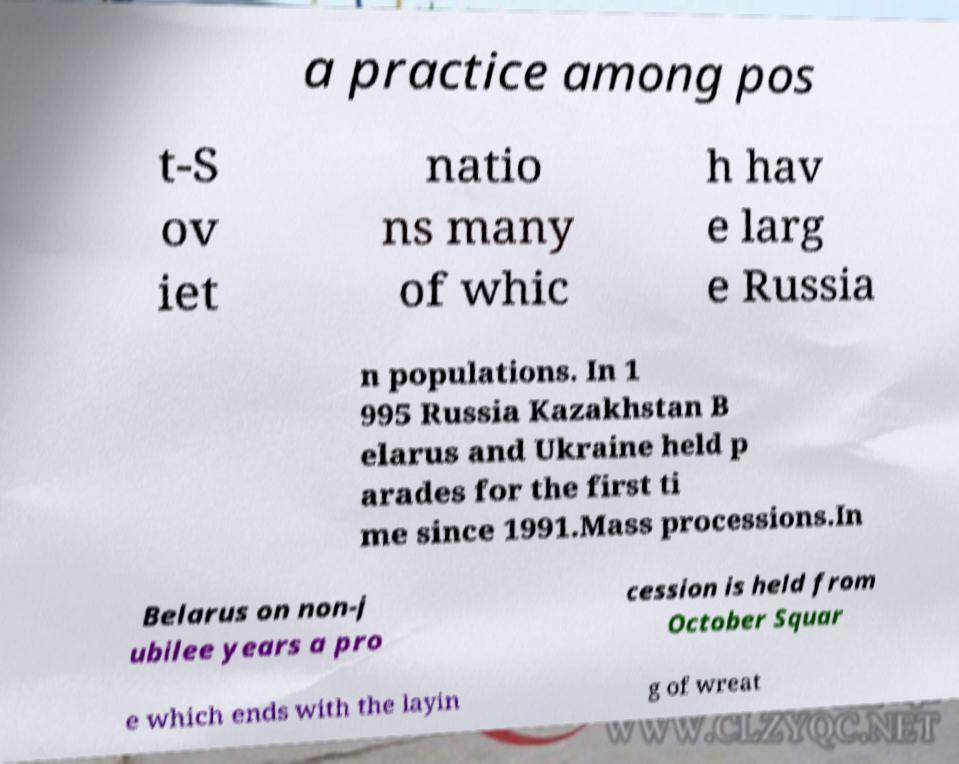Can you accurately transcribe the text from the provided image for me? a practice among pos t-S ov iet natio ns many of whic h hav e larg e Russia n populations. In 1 995 Russia Kazakhstan B elarus and Ukraine held p arades for the first ti me since 1991.Mass processions.In Belarus on non-j ubilee years a pro cession is held from October Squar e which ends with the layin g of wreat 